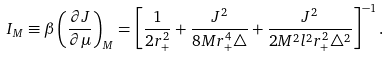<formula> <loc_0><loc_0><loc_500><loc_500>I _ { M } \equiv \beta \left ( \frac { \partial J } { \partial \mu } \right ) _ { M } = \left [ \frac { 1 } { 2 r _ { + } ^ { 2 } } + \frac { J ^ { 2 } } { 8 M r _ { + } ^ { 4 } \triangle } + \frac { J ^ { 2 } } { 2 M ^ { 2 } l ^ { 2 } r _ { + } ^ { 2 } \triangle ^ { 2 } } \right ] ^ { - 1 } .</formula> 